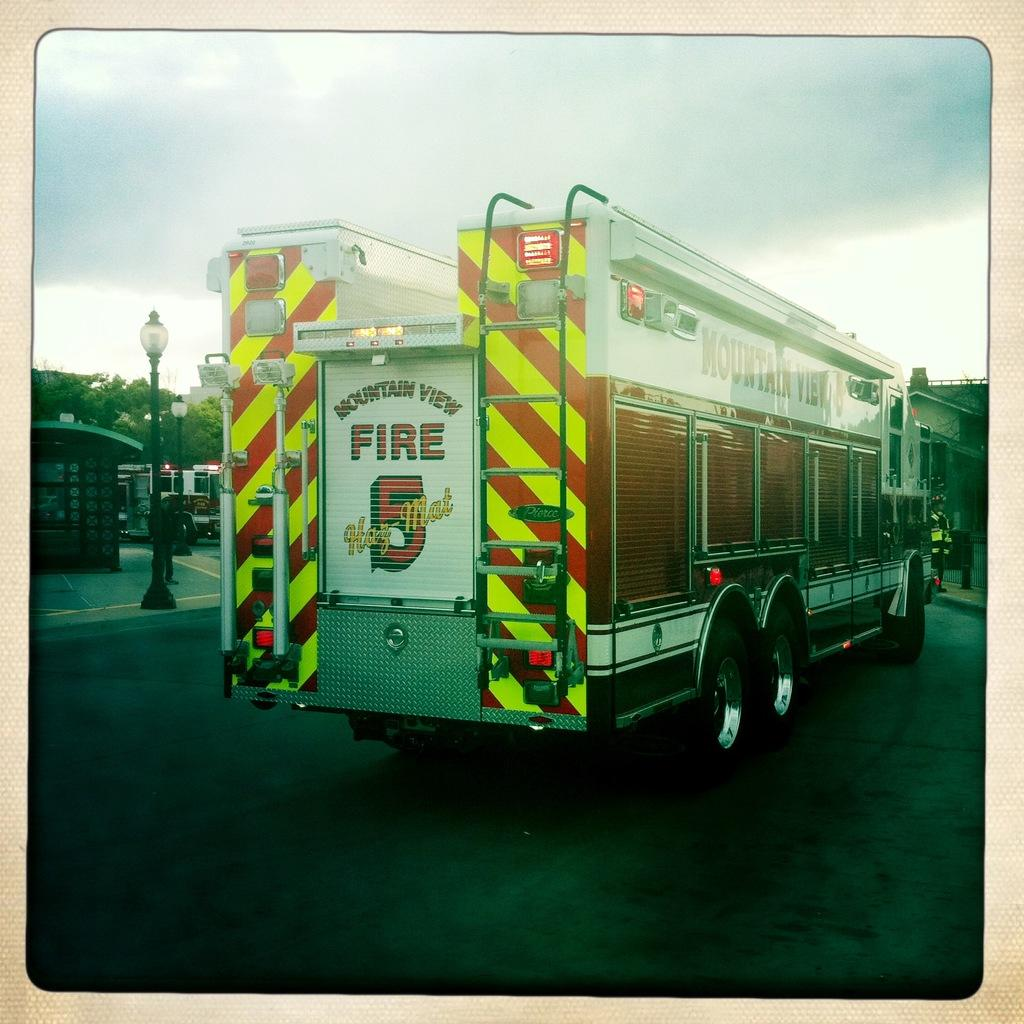What can be seen on the road in the image? There are vehicles on the road in the image. What is visible in the background of the image? There are trees, buildings, street lights, and the sky visible in the background of the image. What else can be seen on the ground in the background of the image? There are other objects on the ground in the background of the image. What type of pigs can be seen feeling shame in the image? There are no pigs present in the image, and therefore no such emotions can be observed. 